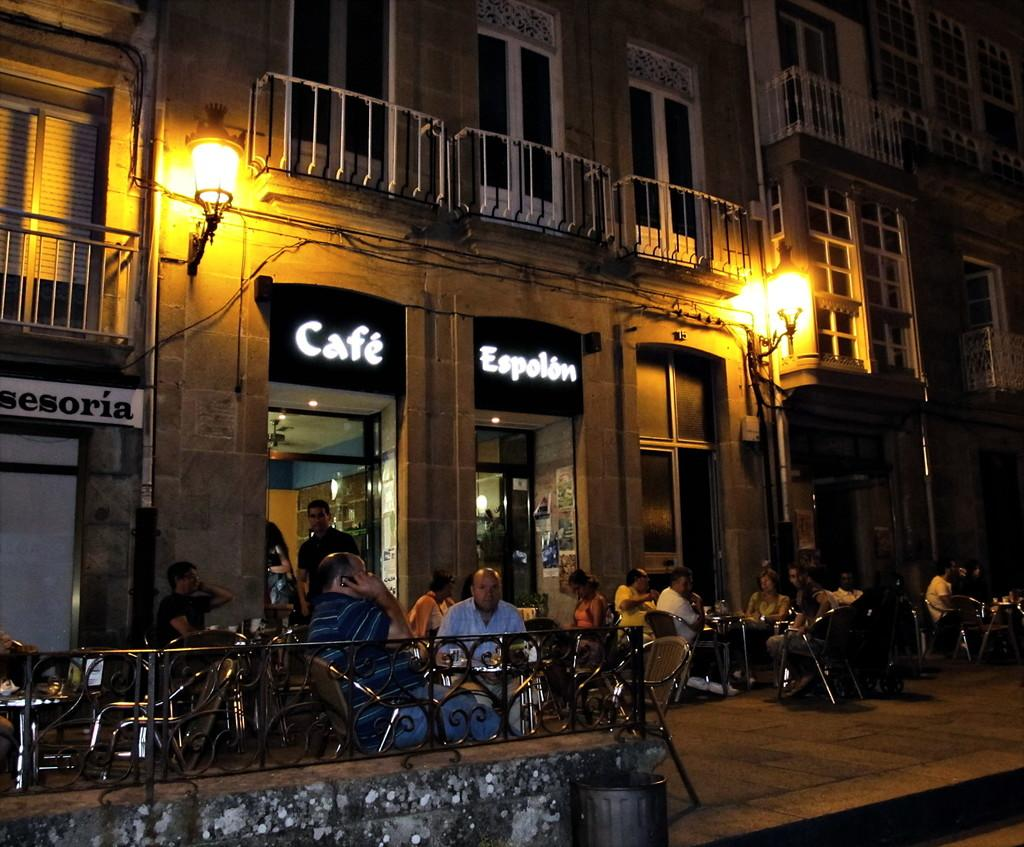<image>
Describe the image concisely. Two signs over a door that say Cafe and Espolion 